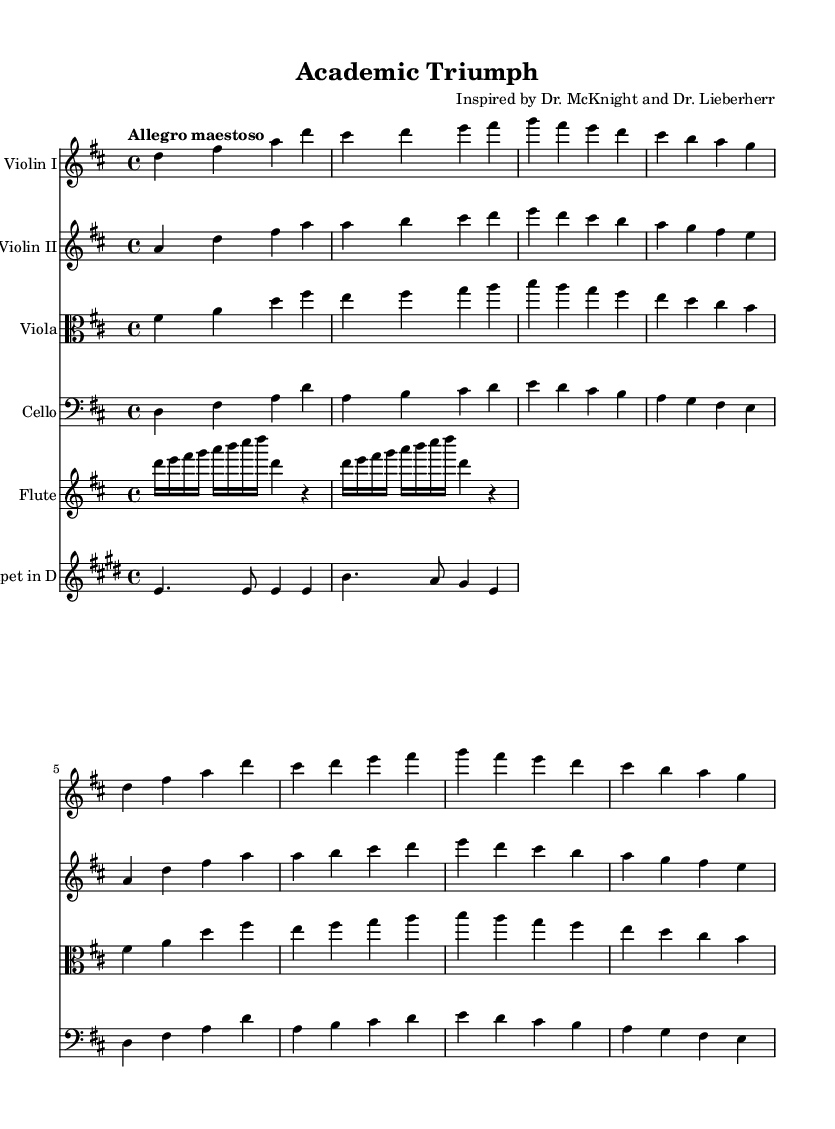What is the key signature of this music? The key signature is D major, which has two sharps: F# and C#. You can identify it by looking at the key signature at the beginning of the staff.
Answer: D major What is the time signature of this piece? The time signature is 4/4, indicated at the beginning of the score. This means there are four beats per measure and the quarter note gets one beat.
Answer: 4/4 What is the tempo marking for this composition? The tempo marking is "Allegro maestoso," which indicates a fast and majestic pace. It can be found indicated at the top of the score.
Answer: Allegro maestoso Which instruments are featured in this orchestral work? The instruments featured include Violin I, Violin II, Viola, Cello, Flute, and Trumpet in D. This can be noted from the individual staffs labeled with each instrument's name.
Answer: Violin I, Violin II, Viola, Cello, Flute, Trumpet in D How many measures are in the introduction section? The introduction consists of 8 measures, counted by identifying the distinct lines of music before the Theme A begins. Each group of notes between the bar lines represents one measure.
Answer: 8 What is the texture of the music primarily, based on the instrumentation? The texture is homophonic, as there is a clearly defined melody supported by harmony from the other instruments. This can be discerned by the way the melodies interact and create blocks of sound from the arrangement.
Answer: Homophonic What type of musical form does this work primarily use? This work primarily uses a theme and variations structure. The initial theme is presented and followed by variations indicated in the subsequent sections. This can be understood by looking at the repetition and development of musical ideas throughout the piece.
Answer: Theme and variations 